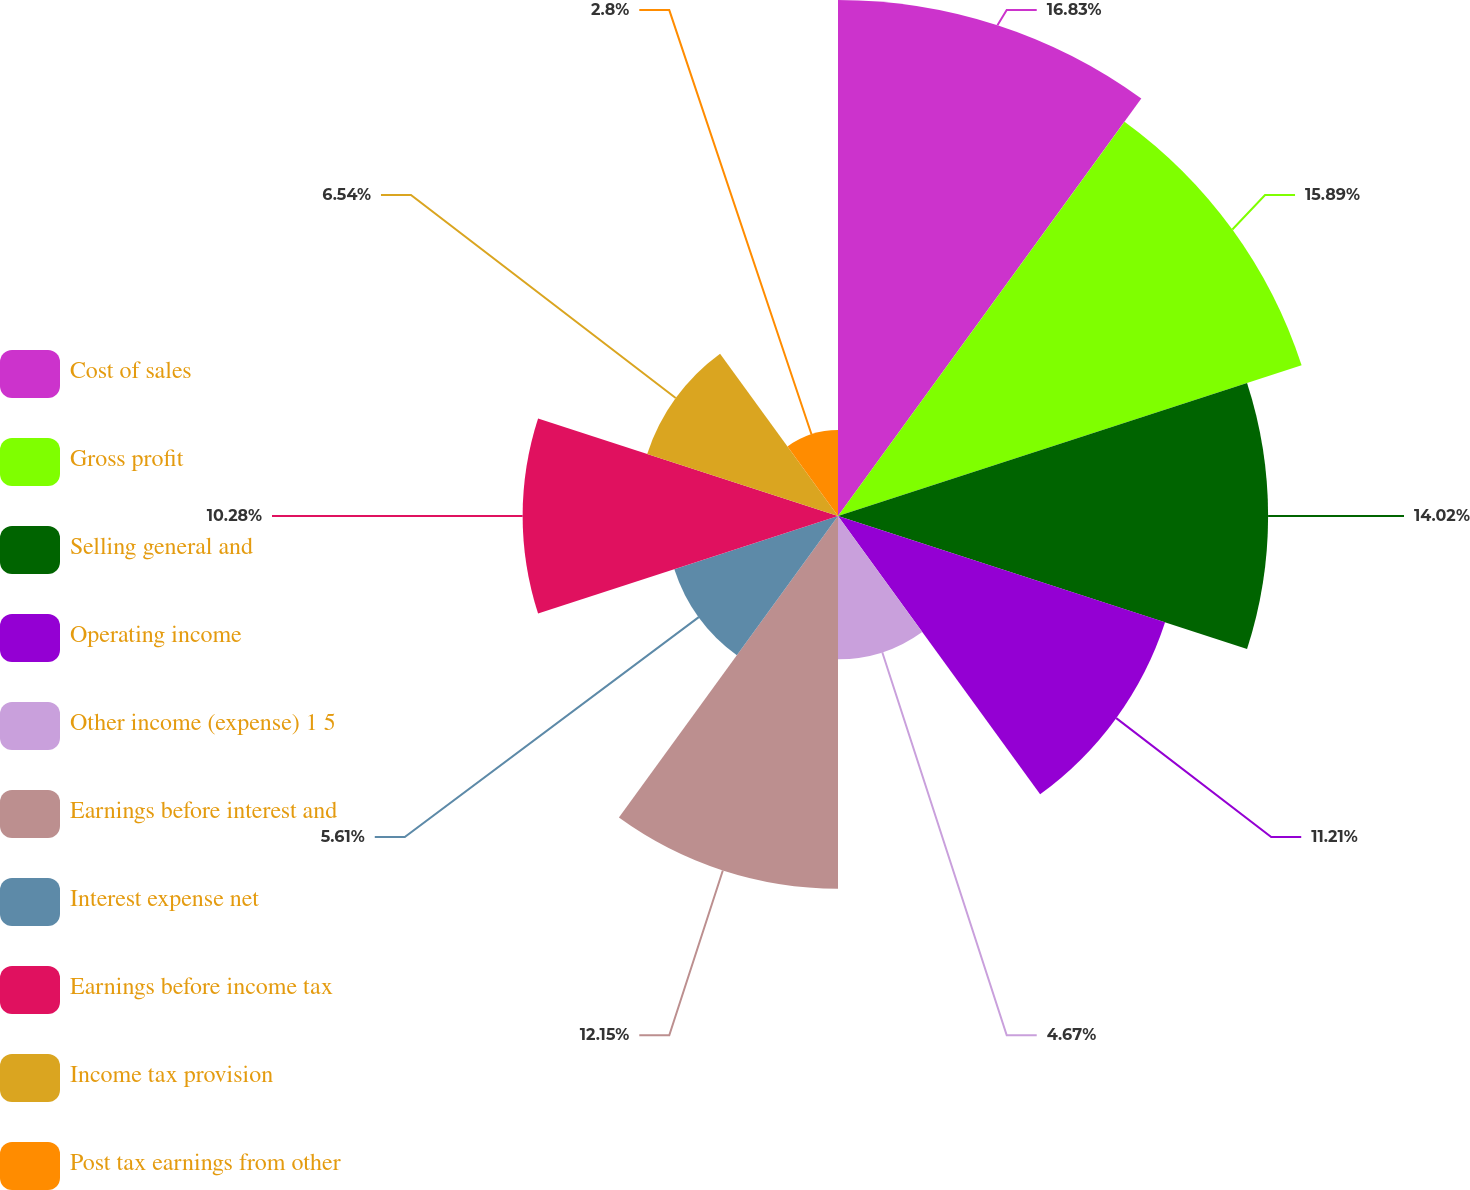<chart> <loc_0><loc_0><loc_500><loc_500><pie_chart><fcel>Cost of sales<fcel>Gross profit<fcel>Selling general and<fcel>Operating income<fcel>Other income (expense) 1 5<fcel>Earnings before interest and<fcel>Interest expense net<fcel>Earnings before income tax<fcel>Income tax provision<fcel>Post tax earnings from other<nl><fcel>16.82%<fcel>15.89%<fcel>14.02%<fcel>11.21%<fcel>4.67%<fcel>12.15%<fcel>5.61%<fcel>10.28%<fcel>6.54%<fcel>2.8%<nl></chart> 